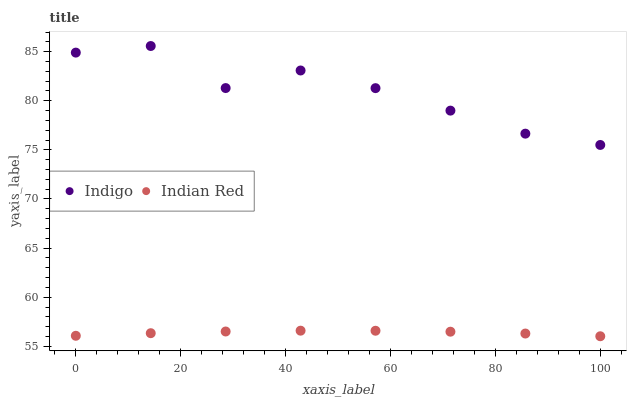Does Indian Red have the minimum area under the curve?
Answer yes or no. Yes. Does Indigo have the maximum area under the curve?
Answer yes or no. Yes. Does Indian Red have the maximum area under the curve?
Answer yes or no. No. Is Indian Red the smoothest?
Answer yes or no. Yes. Is Indigo the roughest?
Answer yes or no. Yes. Is Indian Red the roughest?
Answer yes or no. No. Does Indian Red have the lowest value?
Answer yes or no. Yes. Does Indigo have the highest value?
Answer yes or no. Yes. Does Indian Red have the highest value?
Answer yes or no. No. Is Indian Red less than Indigo?
Answer yes or no. Yes. Is Indigo greater than Indian Red?
Answer yes or no. Yes. Does Indian Red intersect Indigo?
Answer yes or no. No. 